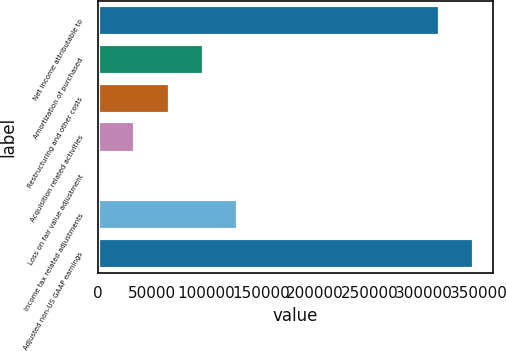<chart> <loc_0><loc_0><loc_500><loc_500><bar_chart><fcel>Net income attributable to<fcel>Amortization of purchased<fcel>Restructuring and other costs<fcel>Acquisition related activities<fcel>Loss on fair value adjustment<fcel>Income tax related adjustments<fcel>Adjusted non-US GAAP earnings<nl><fcel>314213<fcel>97811.3<fcel>66183.2<fcel>34555.1<fcel>2927<fcel>129439<fcel>345841<nl></chart> 